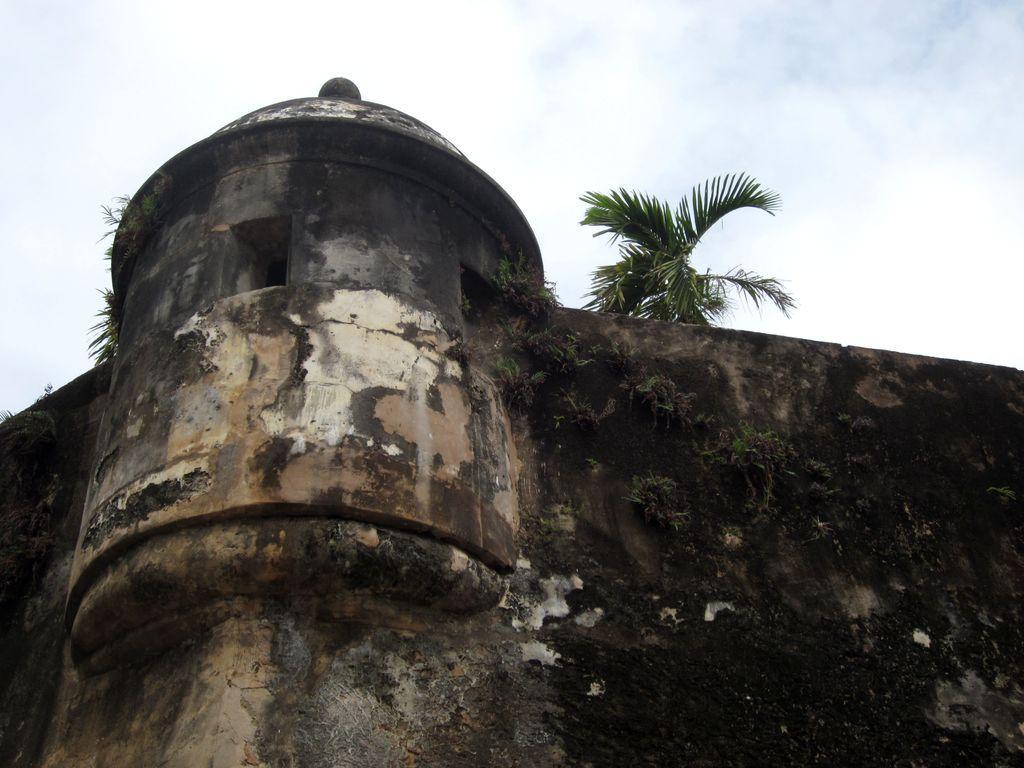Please provide a concise description of this image. In this picture there is a building and there are trees behind the wall and there are plants on the wall. At the top there is sky and there are clouds. 